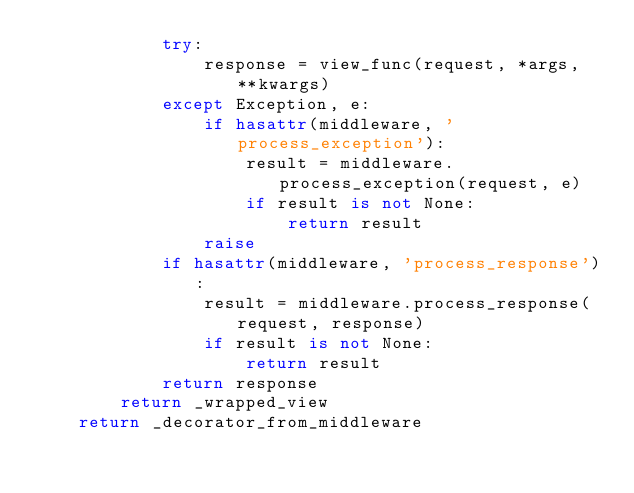<code> <loc_0><loc_0><loc_500><loc_500><_Python_>            try:
                response = view_func(request, *args, **kwargs)
            except Exception, e:
                if hasattr(middleware, 'process_exception'):
                    result = middleware.process_exception(request, e)
                    if result is not None:
                        return result
                raise
            if hasattr(middleware, 'process_response'):
                result = middleware.process_response(request, response)
                if result is not None:
                    return result
            return response
        return _wrapped_view
    return _decorator_from_middleware
</code> 